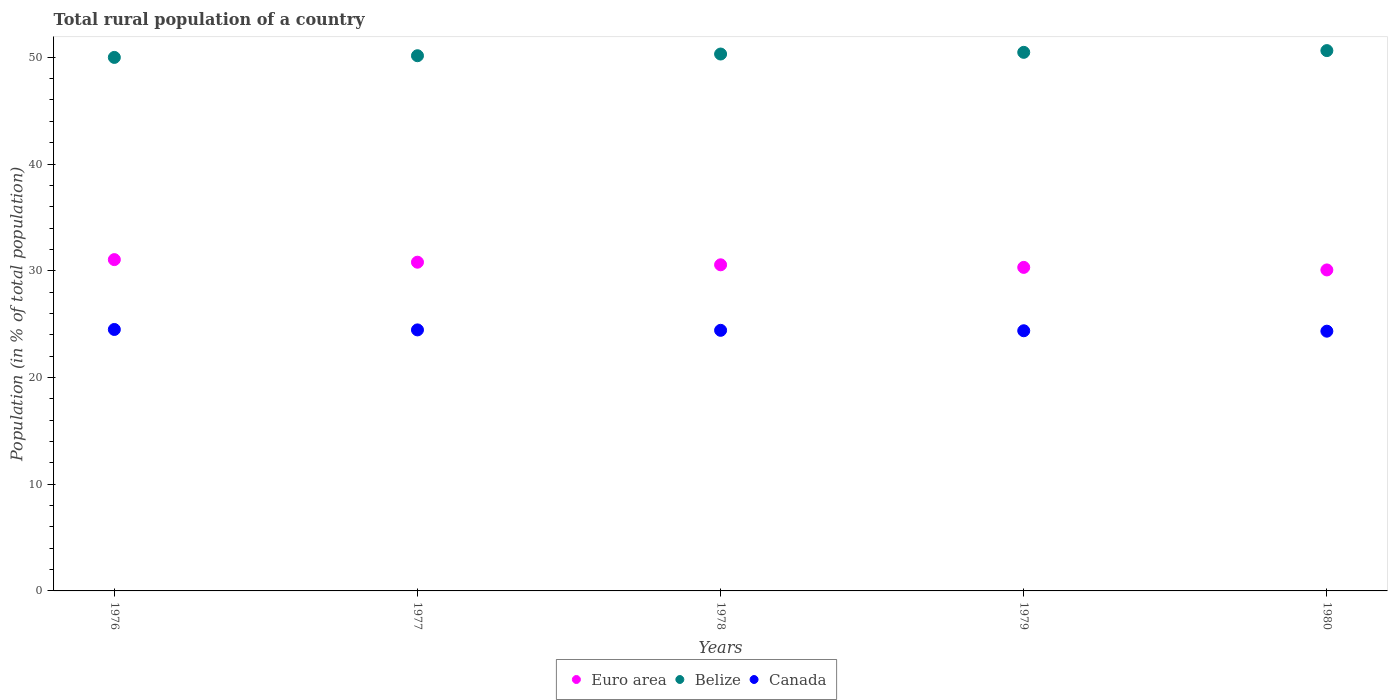How many different coloured dotlines are there?
Your answer should be compact. 3. Is the number of dotlines equal to the number of legend labels?
Offer a terse response. Yes. What is the rural population in Euro area in 1980?
Provide a short and direct response. 30.08. Across all years, what is the maximum rural population in Belize?
Provide a short and direct response. 50.63. Across all years, what is the minimum rural population in Belize?
Offer a very short reply. 49.99. In which year was the rural population in Euro area maximum?
Make the answer very short. 1976. In which year was the rural population in Euro area minimum?
Give a very brief answer. 1980. What is the total rural population in Euro area in the graph?
Give a very brief answer. 152.79. What is the difference between the rural population in Canada in 1977 and that in 1979?
Offer a very short reply. 0.08. What is the difference between the rural population in Canada in 1978 and the rural population in Belize in 1980?
Your answer should be very brief. -26.21. What is the average rural population in Canada per year?
Ensure brevity in your answer.  24.42. In the year 1980, what is the difference between the rural population in Canada and rural population in Belize?
Your answer should be very brief. -26.29. What is the ratio of the rural population in Euro area in 1977 to that in 1979?
Keep it short and to the point. 1.02. Is the rural population in Belize in 1979 less than that in 1980?
Offer a terse response. Yes. Is the difference between the rural population in Canada in 1976 and 1979 greater than the difference between the rural population in Belize in 1976 and 1979?
Keep it short and to the point. Yes. What is the difference between the highest and the second highest rural population in Belize?
Provide a short and direct response. 0.16. What is the difference between the highest and the lowest rural population in Canada?
Your response must be concise. 0.16. In how many years, is the rural population in Euro area greater than the average rural population in Euro area taken over all years?
Make the answer very short. 2. Is it the case that in every year, the sum of the rural population in Canada and rural population in Belize  is greater than the rural population in Euro area?
Ensure brevity in your answer.  Yes. Does the rural population in Euro area monotonically increase over the years?
Your answer should be compact. No. Is the rural population in Euro area strictly less than the rural population in Belize over the years?
Provide a short and direct response. Yes. How many dotlines are there?
Your answer should be compact. 3. What is the difference between two consecutive major ticks on the Y-axis?
Offer a very short reply. 10. Are the values on the major ticks of Y-axis written in scientific E-notation?
Keep it short and to the point. No. Does the graph contain any zero values?
Ensure brevity in your answer.  No. Does the graph contain grids?
Make the answer very short. No. How many legend labels are there?
Keep it short and to the point. 3. What is the title of the graph?
Give a very brief answer. Total rural population of a country. Does "Bahrain" appear as one of the legend labels in the graph?
Provide a succinct answer. No. What is the label or title of the X-axis?
Give a very brief answer. Years. What is the label or title of the Y-axis?
Your answer should be very brief. Population (in % of total population). What is the Population (in % of total population) in Euro area in 1976?
Provide a succinct answer. 31.04. What is the Population (in % of total population) in Belize in 1976?
Make the answer very short. 49.99. What is the Population (in % of total population) of Canada in 1976?
Ensure brevity in your answer.  24.5. What is the Population (in % of total population) in Euro area in 1977?
Keep it short and to the point. 30.8. What is the Population (in % of total population) in Belize in 1977?
Offer a very short reply. 50.15. What is the Population (in % of total population) in Canada in 1977?
Offer a terse response. 24.46. What is the Population (in % of total population) of Euro area in 1978?
Provide a short and direct response. 30.56. What is the Population (in % of total population) of Belize in 1978?
Offer a very short reply. 50.3. What is the Population (in % of total population) in Canada in 1978?
Your response must be concise. 24.42. What is the Population (in % of total population) of Euro area in 1979?
Provide a succinct answer. 30.31. What is the Population (in % of total population) in Belize in 1979?
Give a very brief answer. 50.46. What is the Population (in % of total population) in Canada in 1979?
Make the answer very short. 24.38. What is the Population (in % of total population) of Euro area in 1980?
Your answer should be very brief. 30.08. What is the Population (in % of total population) of Belize in 1980?
Your response must be concise. 50.63. What is the Population (in % of total population) of Canada in 1980?
Your answer should be very brief. 24.34. Across all years, what is the maximum Population (in % of total population) in Euro area?
Offer a very short reply. 31.04. Across all years, what is the maximum Population (in % of total population) in Belize?
Provide a short and direct response. 50.63. Across all years, what is the maximum Population (in % of total population) of Canada?
Your answer should be compact. 24.5. Across all years, what is the minimum Population (in % of total population) of Euro area?
Ensure brevity in your answer.  30.08. Across all years, what is the minimum Population (in % of total population) of Belize?
Provide a succinct answer. 49.99. Across all years, what is the minimum Population (in % of total population) of Canada?
Your answer should be very brief. 24.34. What is the total Population (in % of total population) in Euro area in the graph?
Provide a succinct answer. 152.79. What is the total Population (in % of total population) of Belize in the graph?
Give a very brief answer. 251.53. What is the total Population (in % of total population) of Canada in the graph?
Offer a terse response. 122.08. What is the difference between the Population (in % of total population) in Euro area in 1976 and that in 1977?
Keep it short and to the point. 0.24. What is the difference between the Population (in % of total population) of Belize in 1976 and that in 1977?
Ensure brevity in your answer.  -0.16. What is the difference between the Population (in % of total population) in Euro area in 1976 and that in 1978?
Give a very brief answer. 0.49. What is the difference between the Population (in % of total population) of Belize in 1976 and that in 1978?
Offer a terse response. -0.32. What is the difference between the Population (in % of total population) in Euro area in 1976 and that in 1979?
Ensure brevity in your answer.  0.73. What is the difference between the Population (in % of total population) of Belize in 1976 and that in 1979?
Offer a terse response. -0.47. What is the difference between the Population (in % of total population) of Canada in 1976 and that in 1979?
Keep it short and to the point. 0.12. What is the difference between the Population (in % of total population) of Euro area in 1976 and that in 1980?
Your response must be concise. 0.97. What is the difference between the Population (in % of total population) of Belize in 1976 and that in 1980?
Provide a succinct answer. -0.64. What is the difference between the Population (in % of total population) of Canada in 1976 and that in 1980?
Ensure brevity in your answer.  0.16. What is the difference between the Population (in % of total population) of Euro area in 1977 and that in 1978?
Your answer should be very brief. 0.24. What is the difference between the Population (in % of total population) of Belize in 1977 and that in 1978?
Ensure brevity in your answer.  -0.16. What is the difference between the Population (in % of total population) in Canada in 1977 and that in 1978?
Your answer should be very brief. 0.04. What is the difference between the Population (in % of total population) of Euro area in 1977 and that in 1979?
Offer a terse response. 0.49. What is the difference between the Population (in % of total population) in Belize in 1977 and that in 1979?
Offer a terse response. -0.32. What is the difference between the Population (in % of total population) in Canada in 1977 and that in 1979?
Provide a short and direct response. 0.08. What is the difference between the Population (in % of total population) of Euro area in 1977 and that in 1980?
Your answer should be very brief. 0.72. What is the difference between the Population (in % of total population) in Belize in 1977 and that in 1980?
Ensure brevity in your answer.  -0.48. What is the difference between the Population (in % of total population) in Canada in 1977 and that in 1980?
Offer a very short reply. 0.12. What is the difference between the Population (in % of total population) in Euro area in 1978 and that in 1979?
Provide a short and direct response. 0.24. What is the difference between the Population (in % of total population) in Belize in 1978 and that in 1979?
Make the answer very short. -0.16. What is the difference between the Population (in % of total population) of Euro area in 1978 and that in 1980?
Provide a succinct answer. 0.48. What is the difference between the Population (in % of total population) in Belize in 1978 and that in 1980?
Your answer should be very brief. -0.32. What is the difference between the Population (in % of total population) in Euro area in 1979 and that in 1980?
Offer a terse response. 0.24. What is the difference between the Population (in % of total population) of Belize in 1979 and that in 1980?
Offer a very short reply. -0.16. What is the difference between the Population (in % of total population) of Euro area in 1976 and the Population (in % of total population) of Belize in 1977?
Your answer should be compact. -19.1. What is the difference between the Population (in % of total population) in Euro area in 1976 and the Population (in % of total population) in Canada in 1977?
Offer a terse response. 6.59. What is the difference between the Population (in % of total population) in Belize in 1976 and the Population (in % of total population) in Canada in 1977?
Offer a very short reply. 25.53. What is the difference between the Population (in % of total population) of Euro area in 1976 and the Population (in % of total population) of Belize in 1978?
Provide a short and direct response. -19.26. What is the difference between the Population (in % of total population) of Euro area in 1976 and the Population (in % of total population) of Canada in 1978?
Provide a short and direct response. 6.63. What is the difference between the Population (in % of total population) in Belize in 1976 and the Population (in % of total population) in Canada in 1978?
Ensure brevity in your answer.  25.57. What is the difference between the Population (in % of total population) of Euro area in 1976 and the Population (in % of total population) of Belize in 1979?
Your answer should be very brief. -19.42. What is the difference between the Population (in % of total population) in Euro area in 1976 and the Population (in % of total population) in Canada in 1979?
Offer a terse response. 6.67. What is the difference between the Population (in % of total population) of Belize in 1976 and the Population (in % of total population) of Canada in 1979?
Ensure brevity in your answer.  25.61. What is the difference between the Population (in % of total population) of Euro area in 1976 and the Population (in % of total population) of Belize in 1980?
Give a very brief answer. -19.58. What is the difference between the Population (in % of total population) in Euro area in 1976 and the Population (in % of total population) in Canada in 1980?
Your answer should be compact. 6.71. What is the difference between the Population (in % of total population) of Belize in 1976 and the Population (in % of total population) of Canada in 1980?
Provide a succinct answer. 25.65. What is the difference between the Population (in % of total population) of Euro area in 1977 and the Population (in % of total population) of Belize in 1978?
Give a very brief answer. -19.5. What is the difference between the Population (in % of total population) in Euro area in 1977 and the Population (in % of total population) in Canada in 1978?
Keep it short and to the point. 6.38. What is the difference between the Population (in % of total population) in Belize in 1977 and the Population (in % of total population) in Canada in 1978?
Provide a succinct answer. 25.73. What is the difference between the Population (in % of total population) in Euro area in 1977 and the Population (in % of total population) in Belize in 1979?
Your answer should be compact. -19.66. What is the difference between the Population (in % of total population) of Euro area in 1977 and the Population (in % of total population) of Canada in 1979?
Offer a very short reply. 6.42. What is the difference between the Population (in % of total population) of Belize in 1977 and the Population (in % of total population) of Canada in 1979?
Your response must be concise. 25.77. What is the difference between the Population (in % of total population) of Euro area in 1977 and the Population (in % of total population) of Belize in 1980?
Your answer should be compact. -19.83. What is the difference between the Population (in % of total population) in Euro area in 1977 and the Population (in % of total population) in Canada in 1980?
Give a very brief answer. 6.46. What is the difference between the Population (in % of total population) of Belize in 1977 and the Population (in % of total population) of Canada in 1980?
Your answer should be very brief. 25.81. What is the difference between the Population (in % of total population) in Euro area in 1978 and the Population (in % of total population) in Belize in 1979?
Ensure brevity in your answer.  -19.91. What is the difference between the Population (in % of total population) in Euro area in 1978 and the Population (in % of total population) in Canada in 1979?
Give a very brief answer. 6.18. What is the difference between the Population (in % of total population) of Belize in 1978 and the Population (in % of total population) of Canada in 1979?
Offer a terse response. 25.93. What is the difference between the Population (in % of total population) in Euro area in 1978 and the Population (in % of total population) in Belize in 1980?
Offer a terse response. -20.07. What is the difference between the Population (in % of total population) in Euro area in 1978 and the Population (in % of total population) in Canada in 1980?
Give a very brief answer. 6.22. What is the difference between the Population (in % of total population) in Belize in 1978 and the Population (in % of total population) in Canada in 1980?
Give a very brief answer. 25.97. What is the difference between the Population (in % of total population) in Euro area in 1979 and the Population (in % of total population) in Belize in 1980?
Give a very brief answer. -20.31. What is the difference between the Population (in % of total population) of Euro area in 1979 and the Population (in % of total population) of Canada in 1980?
Your response must be concise. 5.98. What is the difference between the Population (in % of total population) in Belize in 1979 and the Population (in % of total population) in Canada in 1980?
Offer a terse response. 26.13. What is the average Population (in % of total population) in Euro area per year?
Provide a succinct answer. 30.56. What is the average Population (in % of total population) in Belize per year?
Your answer should be compact. 50.31. What is the average Population (in % of total population) of Canada per year?
Give a very brief answer. 24.42. In the year 1976, what is the difference between the Population (in % of total population) of Euro area and Population (in % of total population) of Belize?
Your response must be concise. -18.95. In the year 1976, what is the difference between the Population (in % of total population) of Euro area and Population (in % of total population) of Canada?
Your response must be concise. 6.55. In the year 1976, what is the difference between the Population (in % of total population) in Belize and Population (in % of total population) in Canada?
Provide a short and direct response. 25.49. In the year 1977, what is the difference between the Population (in % of total population) in Euro area and Population (in % of total population) in Belize?
Keep it short and to the point. -19.35. In the year 1977, what is the difference between the Population (in % of total population) of Euro area and Population (in % of total population) of Canada?
Your response must be concise. 6.34. In the year 1977, what is the difference between the Population (in % of total population) in Belize and Population (in % of total population) in Canada?
Your answer should be very brief. 25.69. In the year 1978, what is the difference between the Population (in % of total population) in Euro area and Population (in % of total population) in Belize?
Make the answer very short. -19.75. In the year 1978, what is the difference between the Population (in % of total population) of Euro area and Population (in % of total population) of Canada?
Make the answer very short. 6.14. In the year 1978, what is the difference between the Population (in % of total population) in Belize and Population (in % of total population) in Canada?
Keep it short and to the point. 25.89. In the year 1979, what is the difference between the Population (in % of total population) in Euro area and Population (in % of total population) in Belize?
Give a very brief answer. -20.15. In the year 1979, what is the difference between the Population (in % of total population) in Euro area and Population (in % of total population) in Canada?
Keep it short and to the point. 5.94. In the year 1979, what is the difference between the Population (in % of total population) of Belize and Population (in % of total population) of Canada?
Provide a succinct answer. 26.09. In the year 1980, what is the difference between the Population (in % of total population) of Euro area and Population (in % of total population) of Belize?
Ensure brevity in your answer.  -20.55. In the year 1980, what is the difference between the Population (in % of total population) of Euro area and Population (in % of total population) of Canada?
Your response must be concise. 5.74. In the year 1980, what is the difference between the Population (in % of total population) in Belize and Population (in % of total population) in Canada?
Give a very brief answer. 26.29. What is the ratio of the Population (in % of total population) in Euro area in 1976 to that in 1977?
Give a very brief answer. 1.01. What is the ratio of the Population (in % of total population) in Euro area in 1976 to that in 1978?
Provide a succinct answer. 1.02. What is the ratio of the Population (in % of total population) of Belize in 1976 to that in 1978?
Offer a terse response. 0.99. What is the ratio of the Population (in % of total population) of Canada in 1976 to that in 1978?
Make the answer very short. 1. What is the ratio of the Population (in % of total population) of Belize in 1976 to that in 1979?
Provide a short and direct response. 0.99. What is the ratio of the Population (in % of total population) of Canada in 1976 to that in 1979?
Your answer should be very brief. 1. What is the ratio of the Population (in % of total population) in Euro area in 1976 to that in 1980?
Keep it short and to the point. 1.03. What is the ratio of the Population (in % of total population) in Belize in 1976 to that in 1980?
Your answer should be compact. 0.99. What is the ratio of the Population (in % of total population) of Canada in 1976 to that in 1980?
Your answer should be very brief. 1.01. What is the ratio of the Population (in % of total population) in Belize in 1977 to that in 1978?
Your response must be concise. 1. What is the ratio of the Population (in % of total population) in Canada in 1977 to that in 1978?
Keep it short and to the point. 1. What is the ratio of the Population (in % of total population) of Belize in 1977 to that in 1979?
Your answer should be compact. 0.99. What is the ratio of the Population (in % of total population) in Euro area in 1977 to that in 1980?
Make the answer very short. 1.02. What is the ratio of the Population (in % of total population) in Belize in 1977 to that in 1980?
Offer a very short reply. 0.99. What is the ratio of the Population (in % of total population) in Euro area in 1978 to that in 1979?
Give a very brief answer. 1.01. What is the ratio of the Population (in % of total population) of Belize in 1978 to that in 1980?
Your response must be concise. 0.99. What is the ratio of the Population (in % of total population) in Euro area in 1979 to that in 1980?
Provide a short and direct response. 1.01. What is the ratio of the Population (in % of total population) of Belize in 1979 to that in 1980?
Your response must be concise. 1. What is the difference between the highest and the second highest Population (in % of total population) of Euro area?
Keep it short and to the point. 0.24. What is the difference between the highest and the second highest Population (in % of total population) of Belize?
Your answer should be very brief. 0.16. What is the difference between the highest and the second highest Population (in % of total population) in Canada?
Your response must be concise. 0.04. What is the difference between the highest and the lowest Population (in % of total population) of Euro area?
Your response must be concise. 0.97. What is the difference between the highest and the lowest Population (in % of total population) of Belize?
Provide a short and direct response. 0.64. What is the difference between the highest and the lowest Population (in % of total population) in Canada?
Offer a terse response. 0.16. 